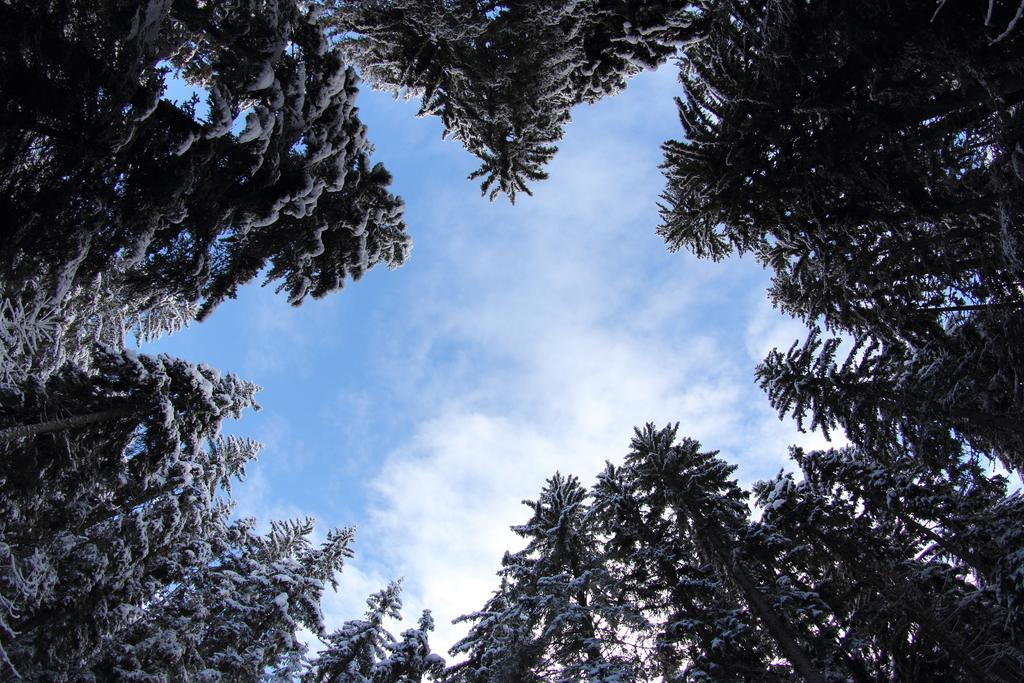What is the perspective of the image? The image is taken from a lower viewpoint. What is the condition of the trees in the image? The trees are covered with snow in the image. What color is the sky in the image? The sky is blue in the image. What can be seen in the sky besides the blue color? Clouds are visible in the sky. What topic are the friends discussing in the image? There are no friends present in the image, so it is not possible to determine what they might be discussing. 